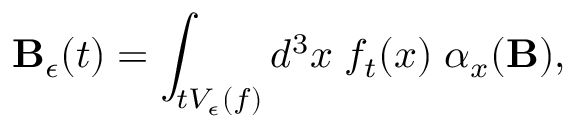Convert formula to latex. <formula><loc_0><loc_0><loc_500><loc_500>{ B } _ { \epsilon } ( t ) = \int _ { t V _ { \epsilon } ( f ) } d ^ { 3 } x \, f _ { t } ( x ) \, \alpha _ { x } ( { B } ) ,</formula> 